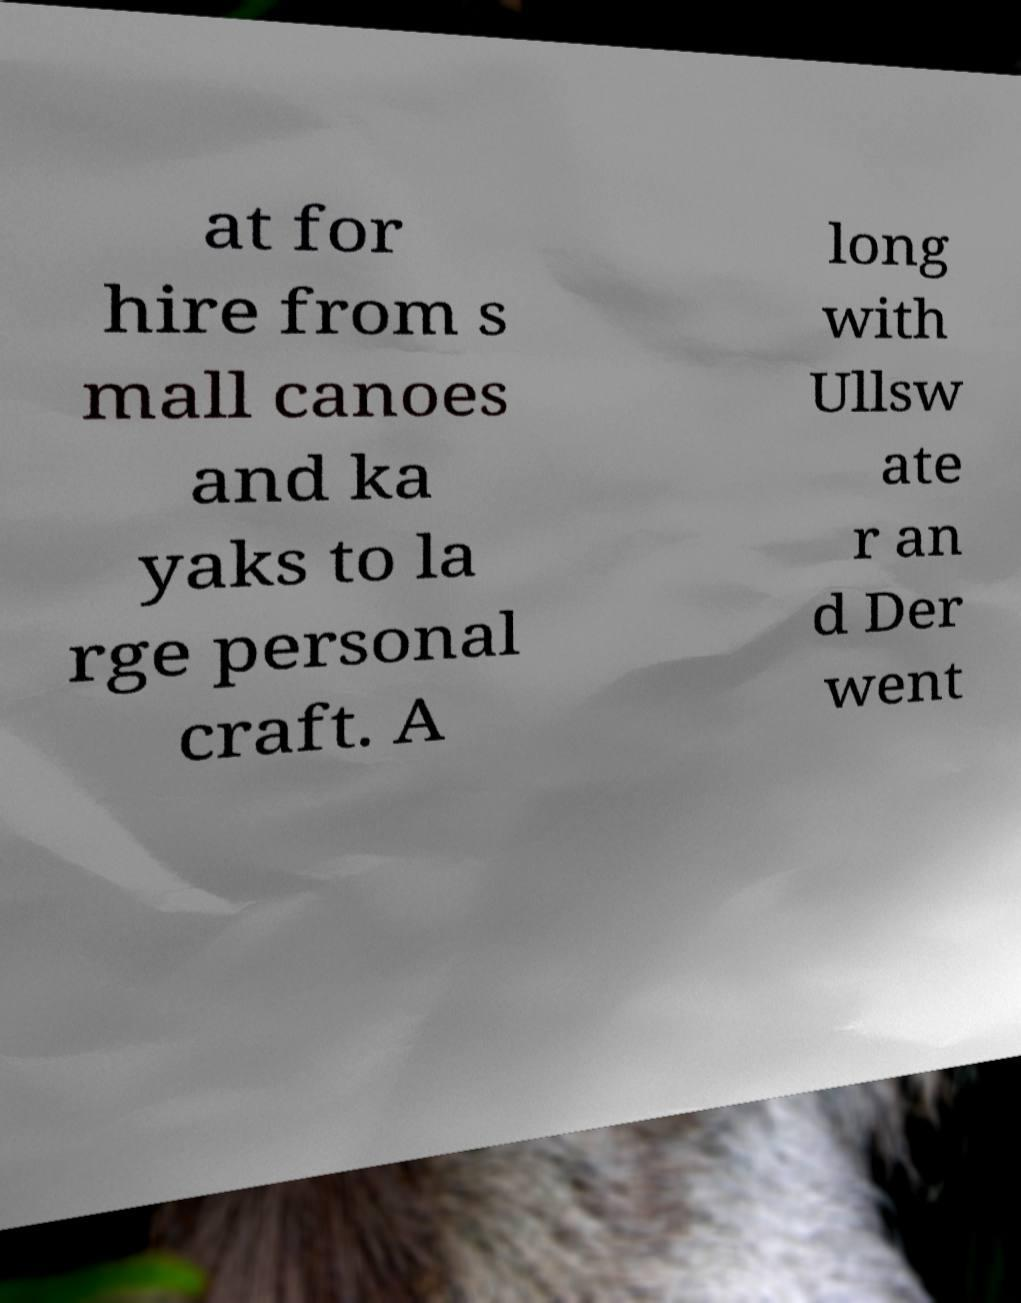For documentation purposes, I need the text within this image transcribed. Could you provide that? at for hire from s mall canoes and ka yaks to la rge personal craft. A long with Ullsw ate r an d Der went 